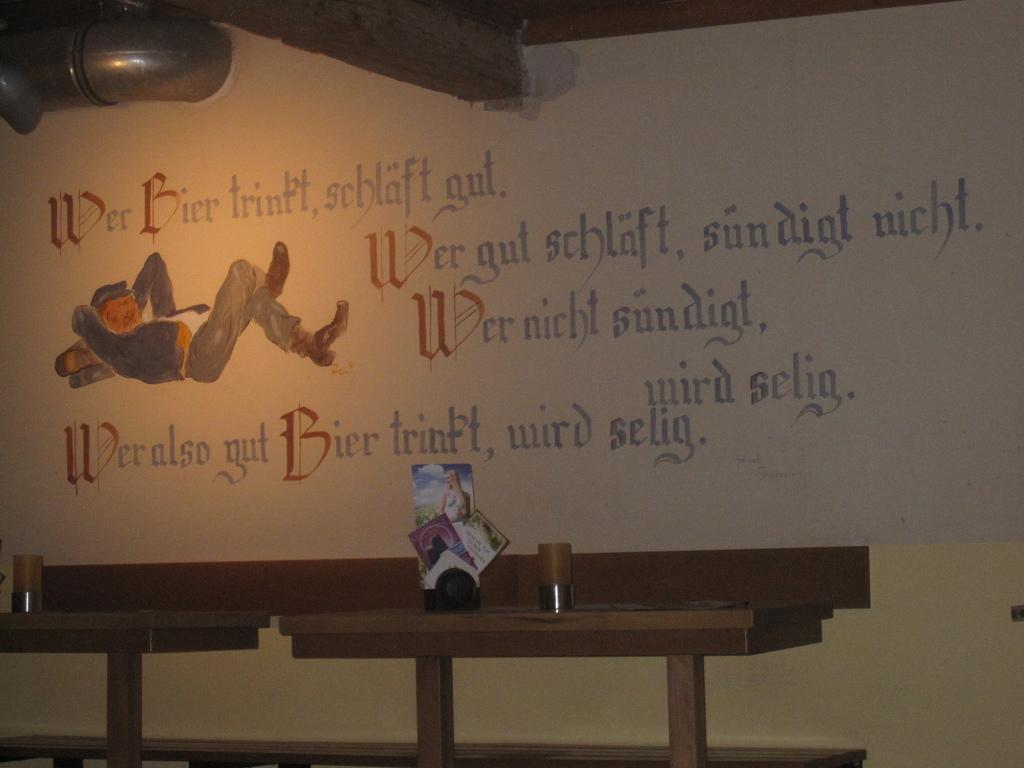What language is this in?
Your answer should be very brief. Unanswerable. What color is the first letter of each sentence?
Your answer should be very brief. Red. 